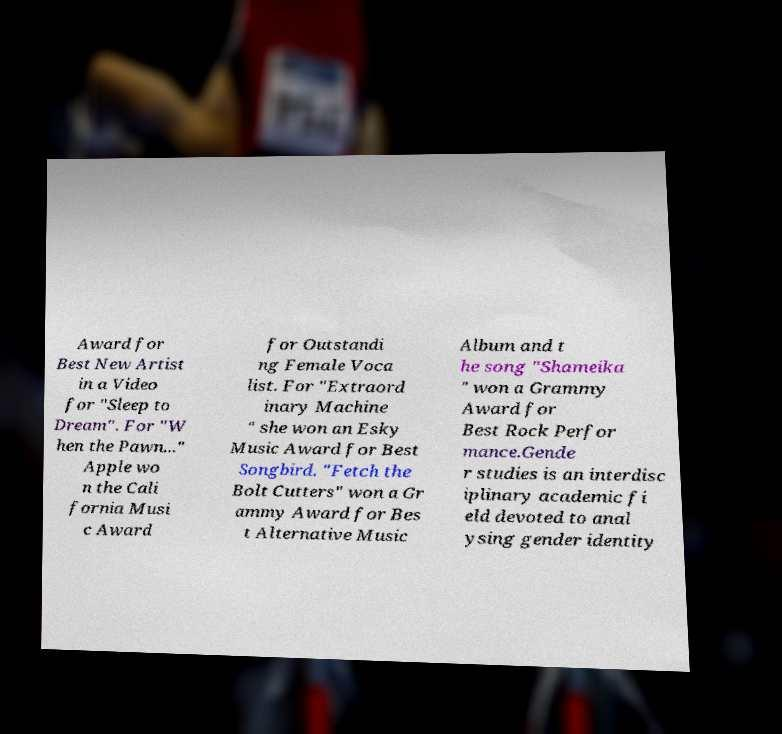Please identify and transcribe the text found in this image. Award for Best New Artist in a Video for "Sleep to Dream". For "W hen the Pawn..." Apple wo n the Cali fornia Musi c Award for Outstandi ng Female Voca list. For "Extraord inary Machine " she won an Esky Music Award for Best Songbird. "Fetch the Bolt Cutters" won a Gr ammy Award for Bes t Alternative Music Album and t he song "Shameika " won a Grammy Award for Best Rock Perfor mance.Gende r studies is an interdisc iplinary academic fi eld devoted to anal ysing gender identity 